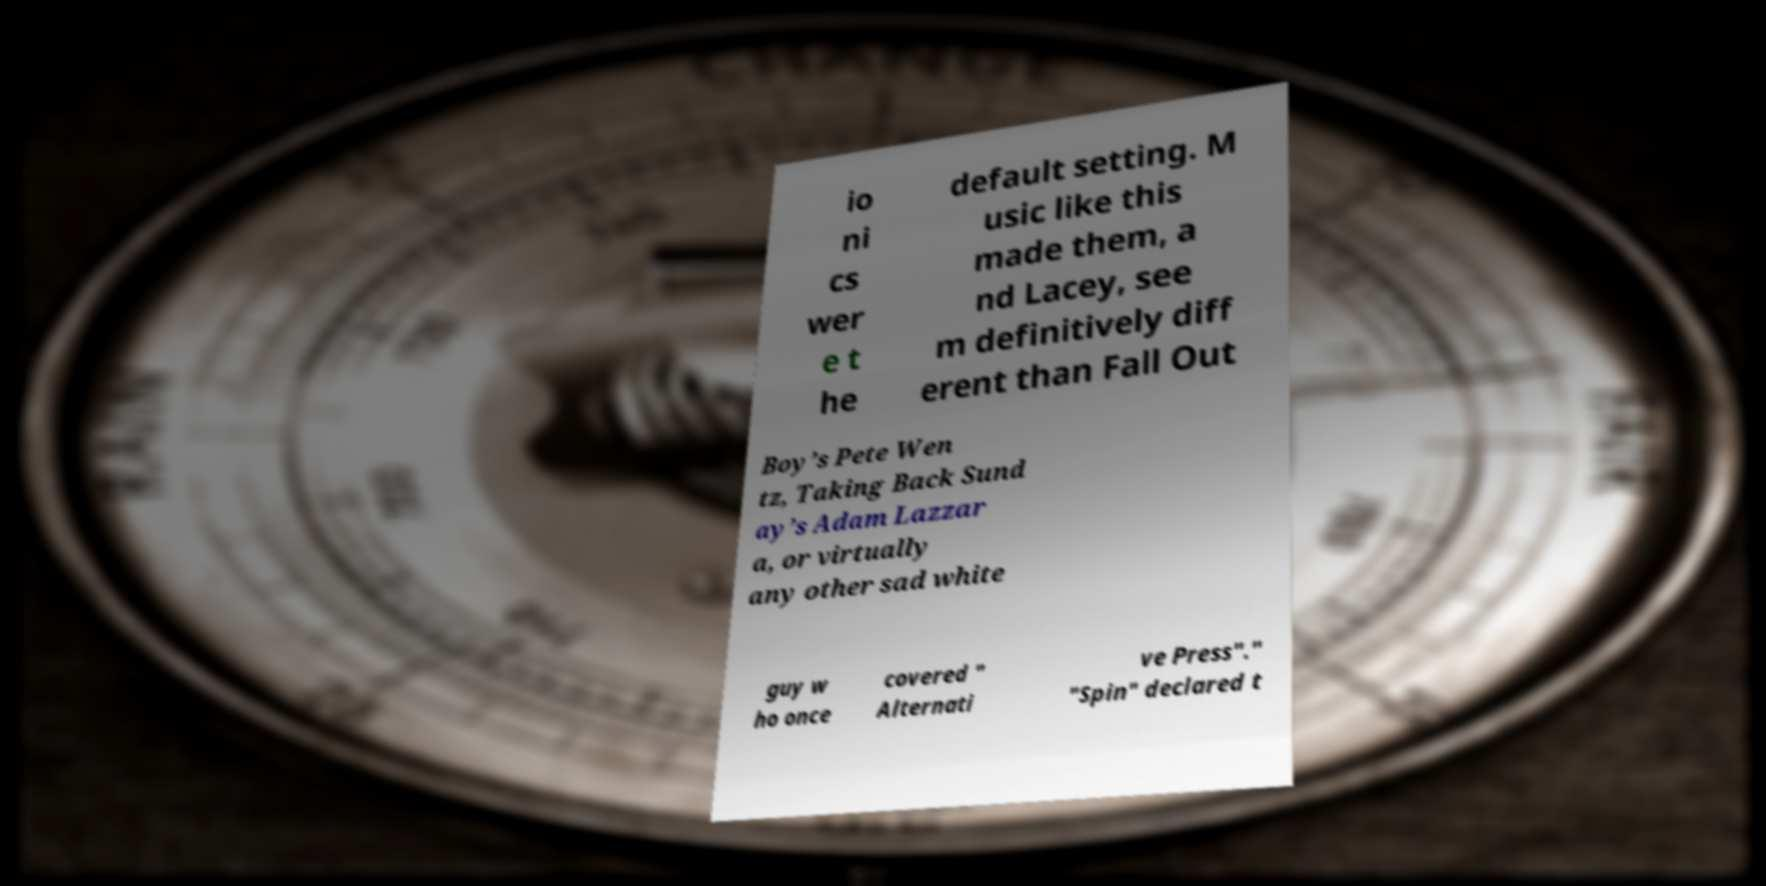What messages or text are displayed in this image? I need them in a readable, typed format. io ni cs wer e t he default setting. M usic like this made them, a nd Lacey, see m definitively diff erent than Fall Out Boy’s Pete Wen tz, Taking Back Sund ay’s Adam Lazzar a, or virtually any other sad white guy w ho once covered " Alternati ve Press"." "Spin" declared t 